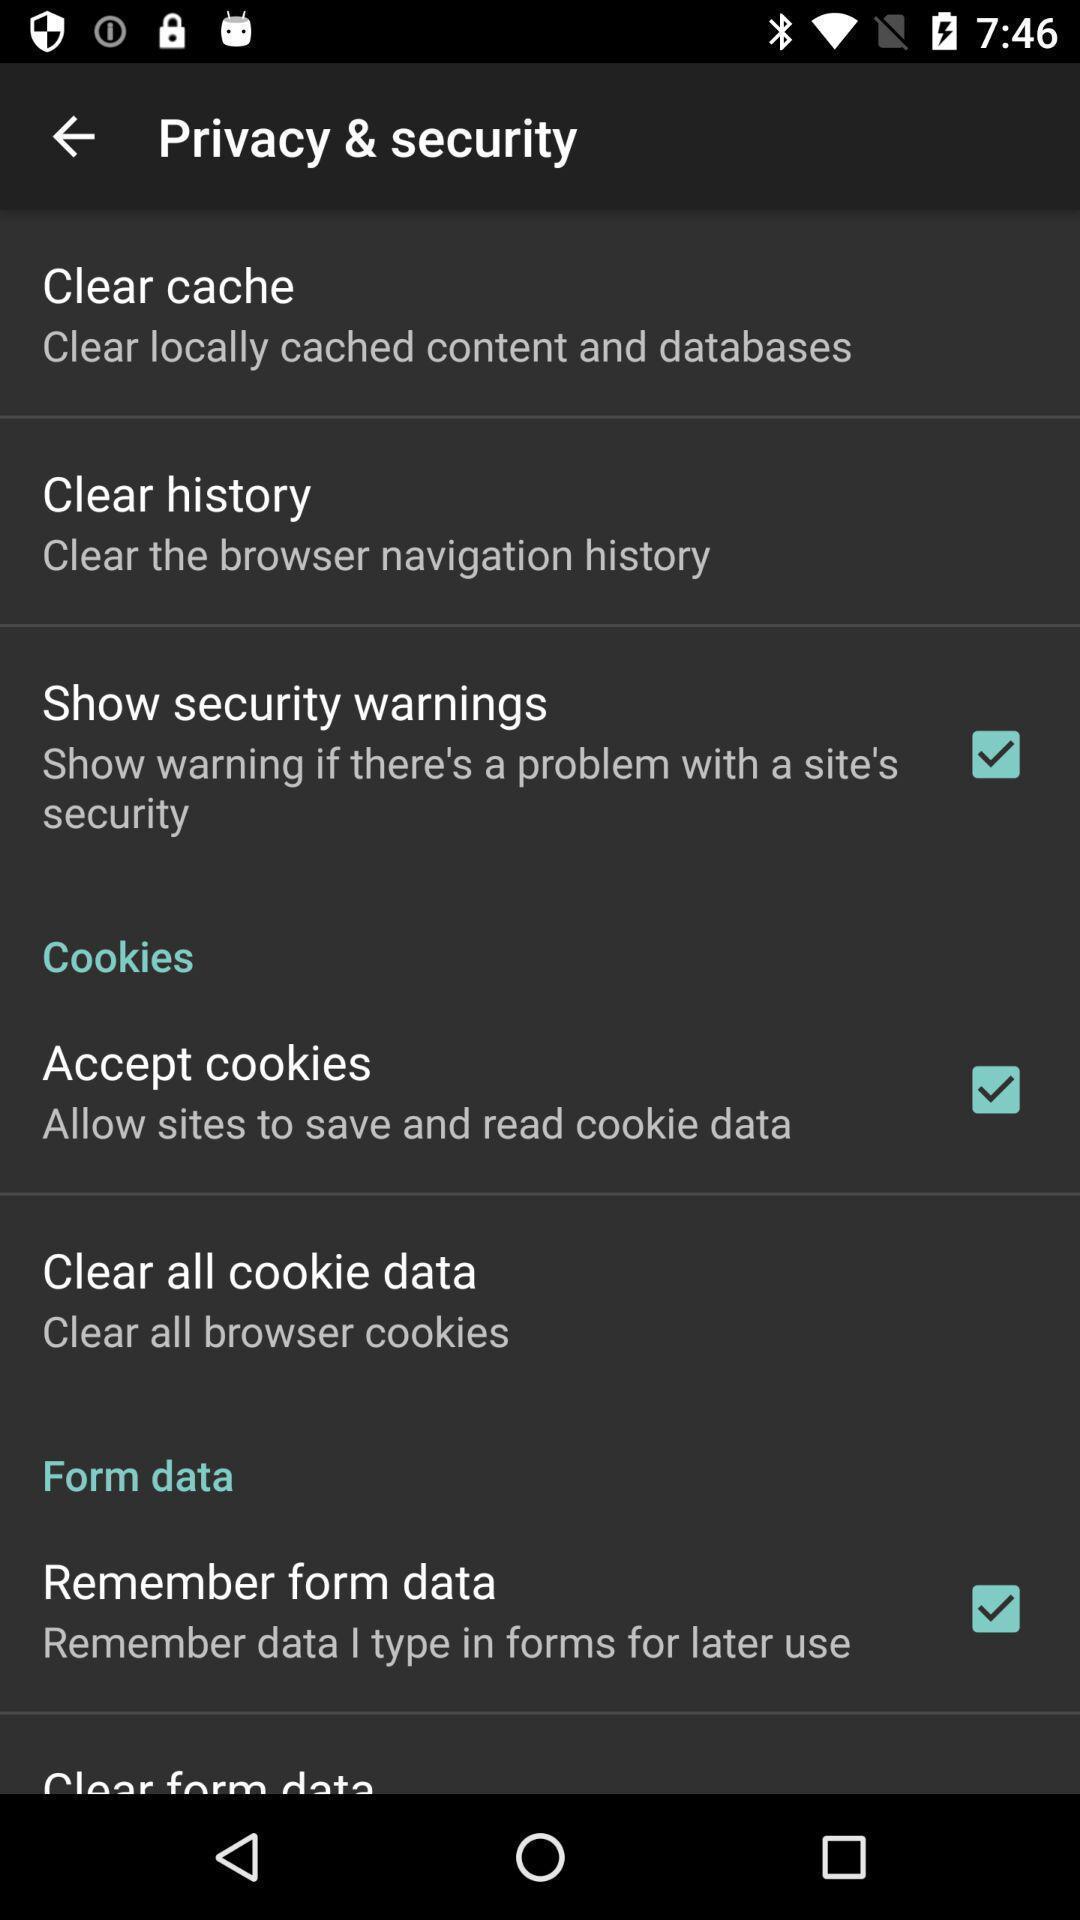Provide a textual representation of this image. Screen showing privacy and security settings page. 